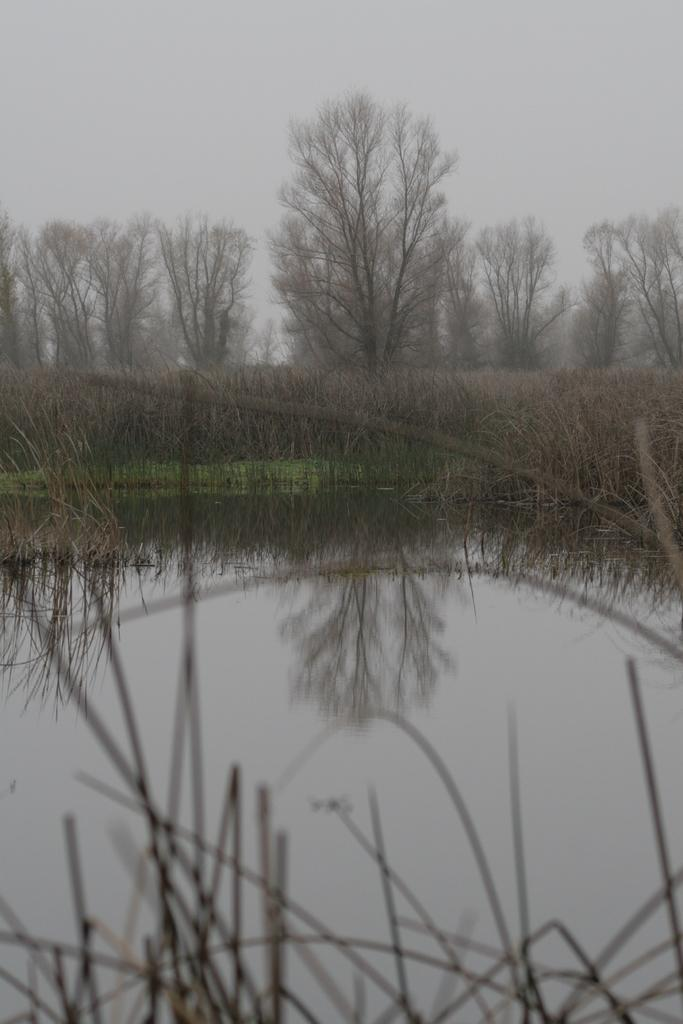What is the setting of the image? The image has an outside view. What can be seen in the foreground of the image? There is a lake in the foreground of the image. What is located in the middle of the image? There are trees in the middle of the image. What is visible in the background of the image? The sky is visible in the background of the image. How many toes are visible in the image? There are no toes visible in the image, as it is an outdoor scene with a lake, trees, and sky. 